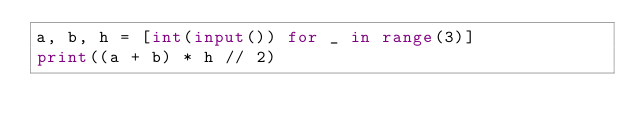<code> <loc_0><loc_0><loc_500><loc_500><_Python_>a, b, h = [int(input()) for _ in range(3)]
print((a + b) * h // 2)
</code> 